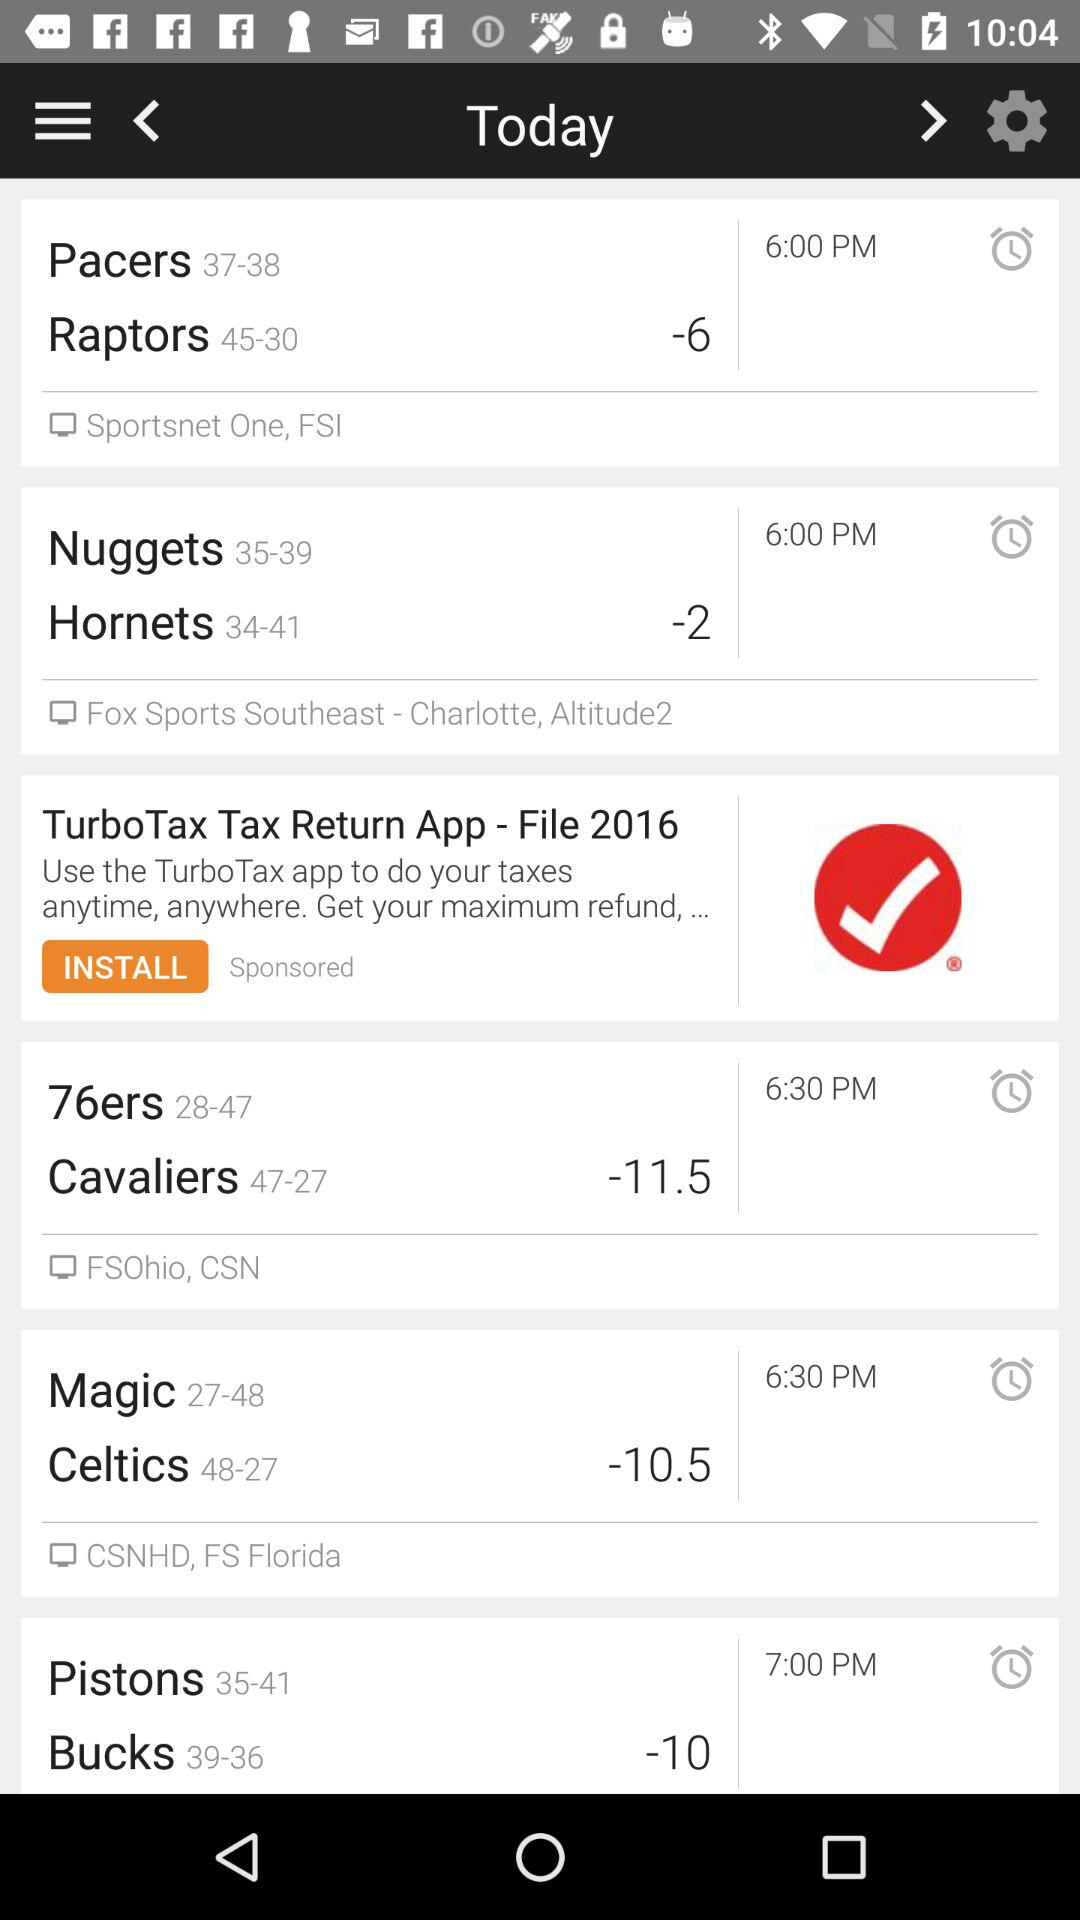What's the range for cavaliers?
When the provided information is insufficient, respond with <no answer>. <no answer> 